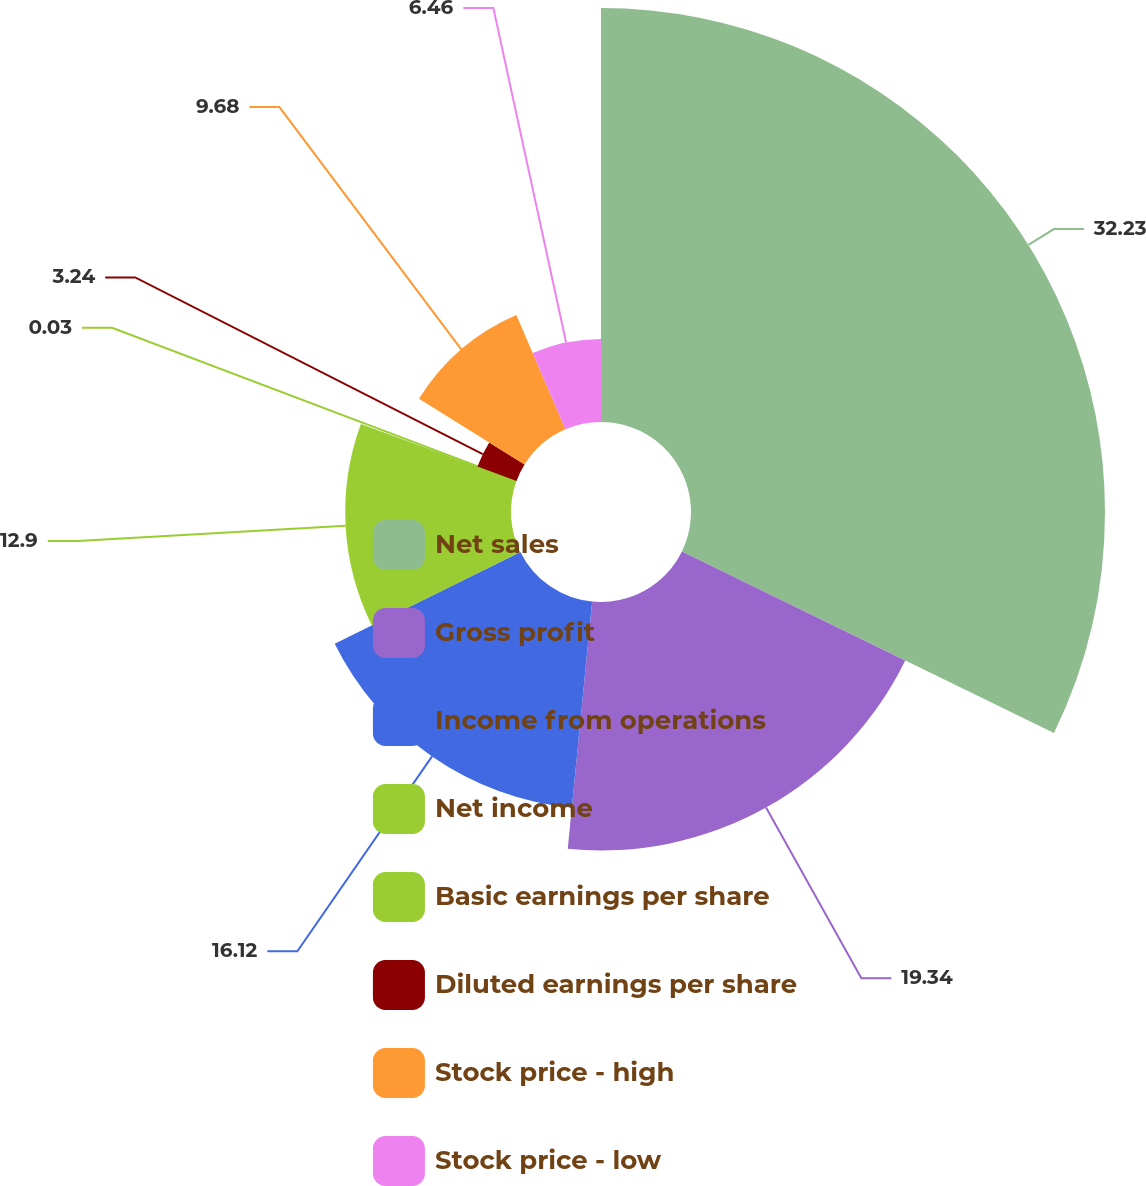Convert chart. <chart><loc_0><loc_0><loc_500><loc_500><pie_chart><fcel>Net sales<fcel>Gross profit<fcel>Income from operations<fcel>Net income<fcel>Basic earnings per share<fcel>Diluted earnings per share<fcel>Stock price - high<fcel>Stock price - low<nl><fcel>32.22%<fcel>19.34%<fcel>16.12%<fcel>12.9%<fcel>0.03%<fcel>3.24%<fcel>9.68%<fcel>6.46%<nl></chart> 